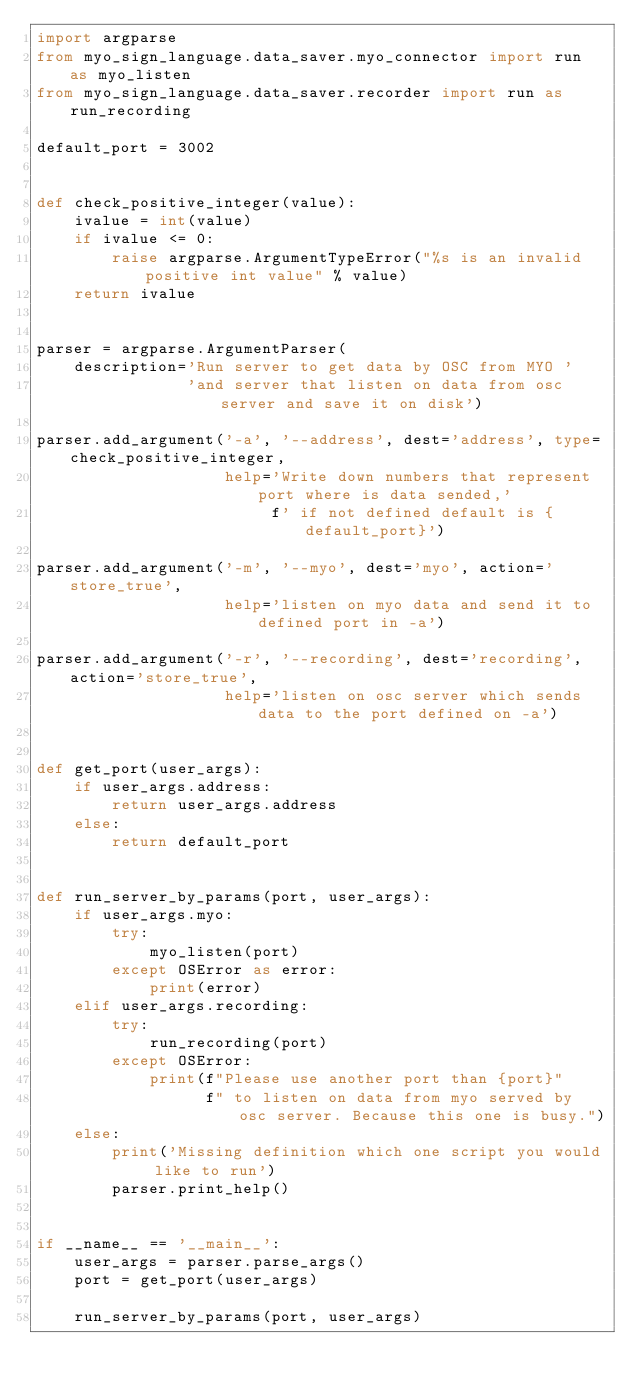Convert code to text. <code><loc_0><loc_0><loc_500><loc_500><_Python_>import argparse
from myo_sign_language.data_saver.myo_connector import run as myo_listen
from myo_sign_language.data_saver.recorder import run as run_recording

default_port = 3002


def check_positive_integer(value):
    ivalue = int(value)
    if ivalue <= 0:
        raise argparse.ArgumentTypeError("%s is an invalid positive int value" % value)
    return ivalue


parser = argparse.ArgumentParser(
    description='Run server to get data by OSC from MYO '
                'and server that listen on data from osc server and save it on disk')

parser.add_argument('-a', '--address', dest='address', type=check_positive_integer,
                    help='Write down numbers that represent port where is data sended,'
                         f' if not defined default is {default_port}')

parser.add_argument('-m', '--myo', dest='myo', action='store_true',
                    help='listen on myo data and send it to defined port in -a')

parser.add_argument('-r', '--recording', dest='recording', action='store_true',
                    help='listen on osc server which sends data to the port defined on -a')


def get_port(user_args):
    if user_args.address:
        return user_args.address
    else:
        return default_port


def run_server_by_params(port, user_args):
    if user_args.myo:
        try:
            myo_listen(port)
        except OSError as error:
            print(error)
    elif user_args.recording:
        try:
            run_recording(port)
        except OSError:
            print(f"Please use another port than {port}"
                  f" to listen on data from myo served by osc server. Because this one is busy.")
    else:
        print('Missing definition which one script you would like to run')
        parser.print_help()


if __name__ == '__main__':
    user_args = parser.parse_args()
    port = get_port(user_args)

    run_server_by_params(port, user_args)
</code> 